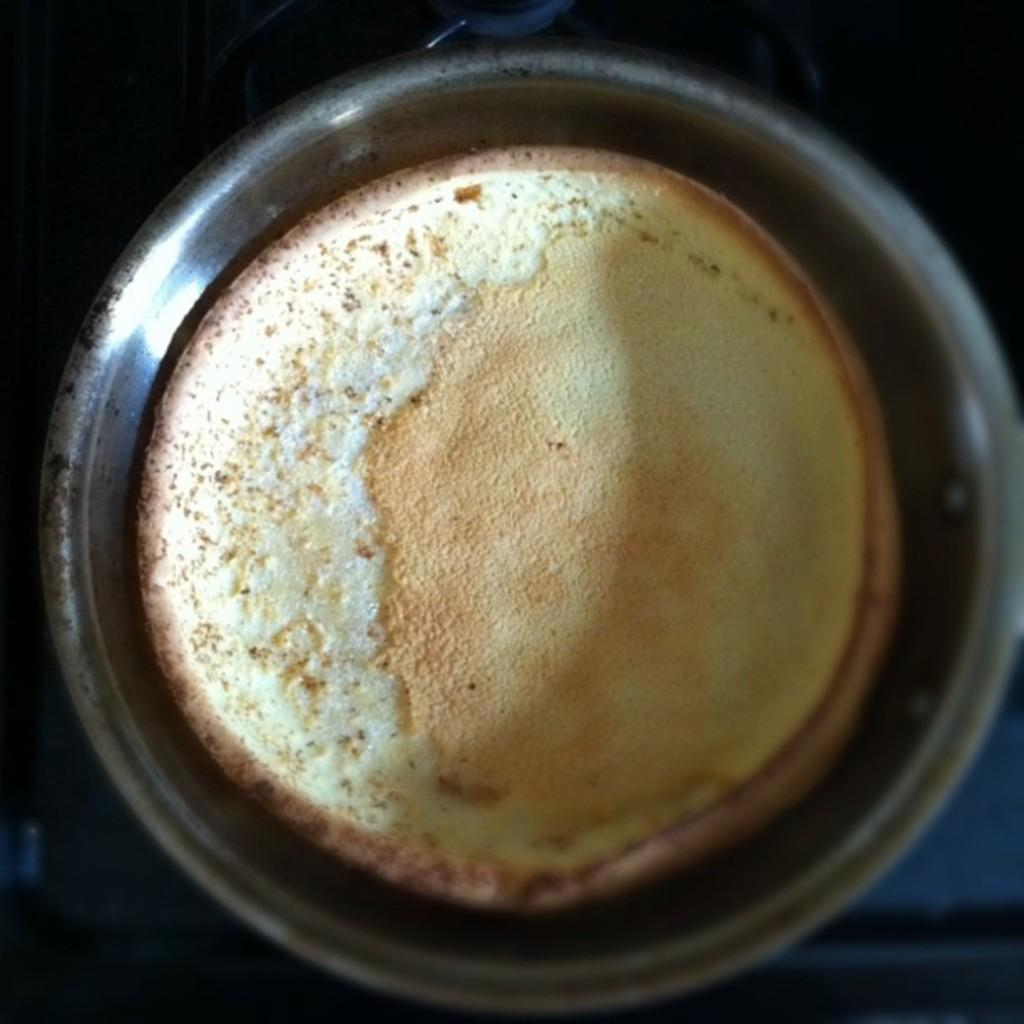What is in the bowl that is visible in the image? There is food in the bowl. Can you describe the background of the image? The background of the image is dark. What flavor of lip balm can be seen in the image? There is no lip balm present in the image. What type of mist is visible in the image? There is no mist present in the image. 